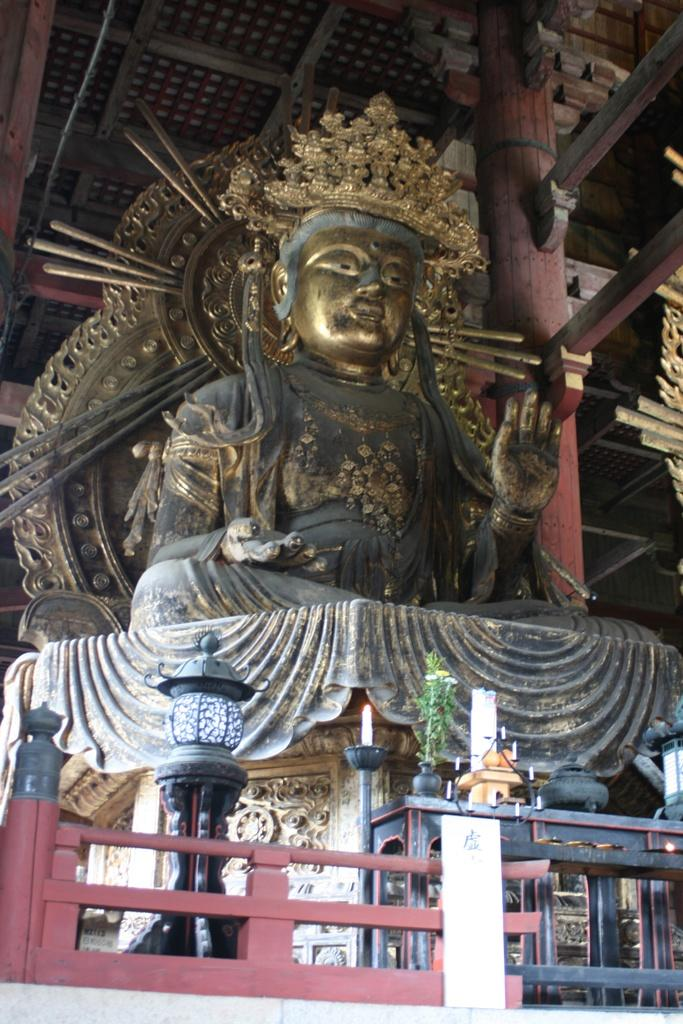What is the main subject in the image? There is a statue in the image. What other objects can be seen in the image? There is a lamp on the left side of the image and a plant in the middle of the image. What type of organization is depicted in the image? There is no organization depicted in the image; it features a statue, a lamp, and a plant. How many feet does the statue have in the image? The statue does not have any feet in the image, as it is likely a freestanding sculpture. 